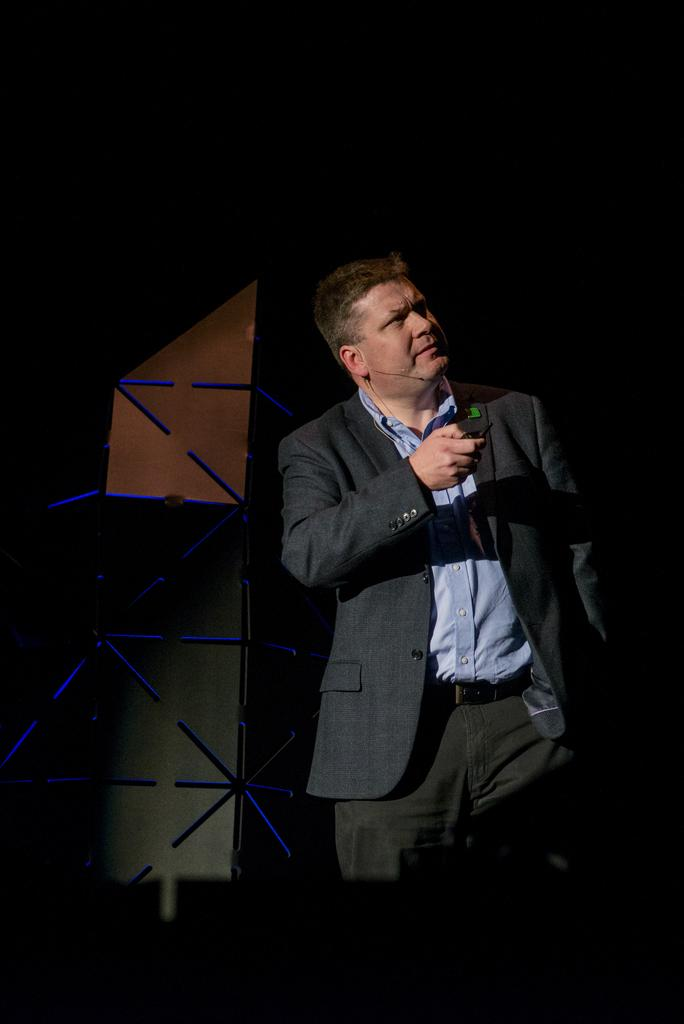Who is present in the image? There is a man in the image. What is the man wearing? The man is wearing a blazer. What is the man holding in the image? The man is holding an object. Can you describe the background of the image? There is an object in the background of the image. How many brothers does the man have in the image? There is no information about the man's brothers in the image. Is the man being attacked by a pipe in the image? There is no pipe or any indication of an attack in the image. 